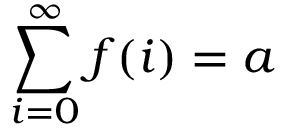Convert formula to latex. <formula><loc_0><loc_0><loc_500><loc_500>\sum _ { i = 0 } ^ { \infty } f ( i ) = a</formula> 